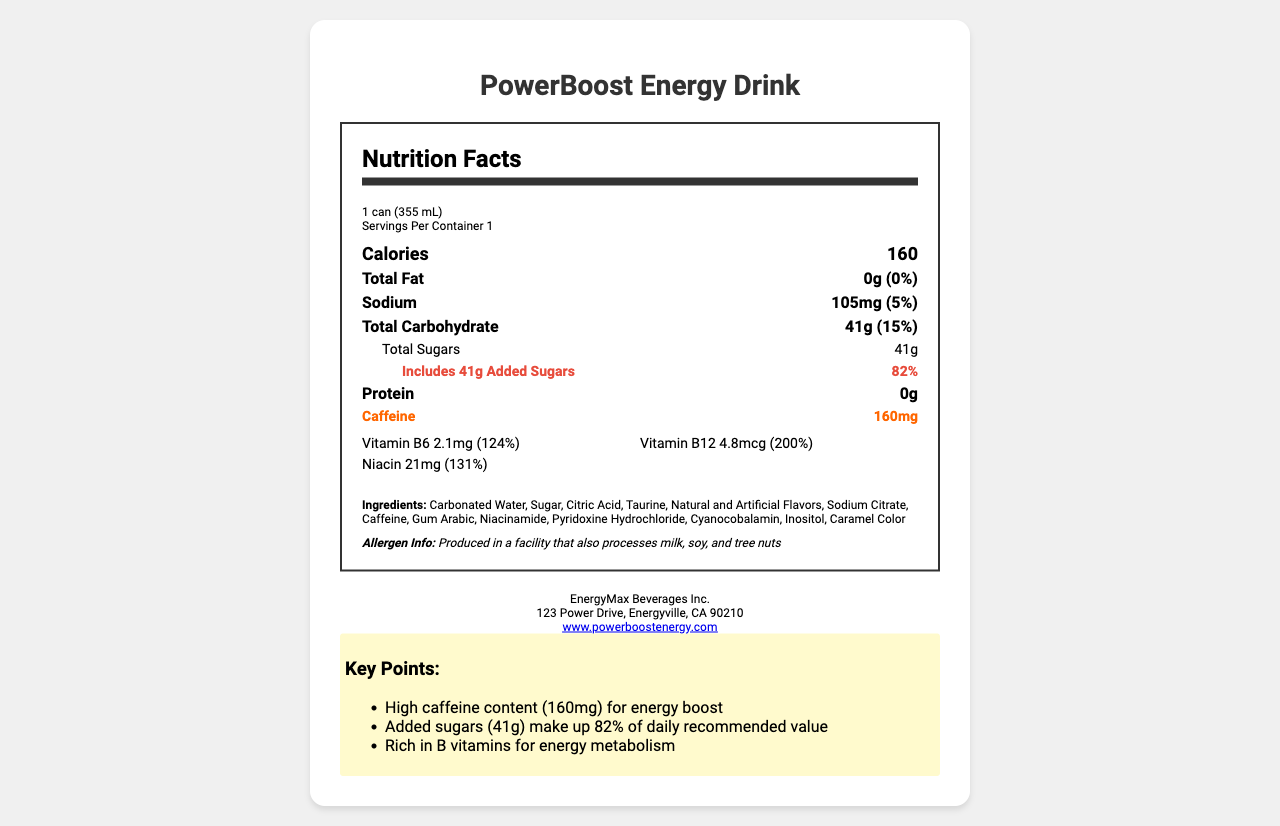What is the serving size for PowerBoost Energy Drink? The serving size is clearly stated at the beginning of the Nutrition Facts label as "1 can (355 mL)."
Answer: 1 can (355 mL) How many calories are in one serving of PowerBoost Energy Drink? The calories per serving are listed in bold and large text as 160.
Answer: 160 What percentage of the daily recommended value of added sugars does one serving of PowerBoost Energy Drink contain? The document states that the drink includes 41g of added sugars, which constitute 82% of the daily recommended value.
Answer: 82% What is the caffeine content in one serving of PowerBoost Energy Drink? The caffeine content is highlighted in bold with a distinctive orange color stating "160mg."
Answer: 160mg Which vitamins are present in PowerBoost Energy Drink and in what quantities? The vitamins and their quantities are listed in a section beneath the main nutritional information, specifying Vitamin B6: 2.1mg, Vitamin B12: 4.8mcg, and Niacin: 21mg.
Answer: Vitamin B6: 2.1mg, Vitamin B12: 4.8mcg, Niacin: 21mg Which nutrient has the highest percentage daily value in this energy drink? 
A. Sodium
B. Vitamin B6
C. Niacin
D. Added Sugars Added sugars have the highest percentage daily value at 82%, as highlighted in red in the document.
Answer: D. Added Sugars Which of the following ingredients is not found in the PowerBoost Energy Drink?
I. Carbonated Water
II. Sucrose
III. Taurine The listed ingredients do not include "Sucrose," but they do include "Carbonated Water" and "Taurine."
Answer: II. Sucrose Are there any protein contents in PowerBoost Energy Drink? The label explicitly states "Protein" with "0g," indicating there is no protein content.
Answer: No Is PowerBoost Energy Drink produced in a facility that processes nuts? The allergen information section notes that the product is "Produced in a facility that also processes milk, soy, and tree nuts."
Answer: Yes Summarize the main features highlighted in the Nutrition Facts label of PowerBoost Energy Drink. The summary captures the key nutritional information, including serving size, calorie count, fat, sodium, carbohydrates, caffeine, vitamins, and potential allergens.
Answer: PowerBoost Energy Drink has a serving size of 1 can (355 mL) with 160 calories. It contains 0g of fat, 105mg of sodium, 41g of carbohydrates (all of which are added sugars, making up 82% of the daily value), and 160mg of caffeine. The drink is rich in Vitamin B6, Vitamin B12, and Niacin. Ingredients include carbonated water, sugar, citric acid, taurine, caffeine, and others. It is produced in a facility that processes milk, soy, and tree nuts. What is the function of Inositol in the PowerBoost Energy Drink? The document does not provide any specific information about the function or benefits of Inositol in the drink.
Answer: Not enough information 